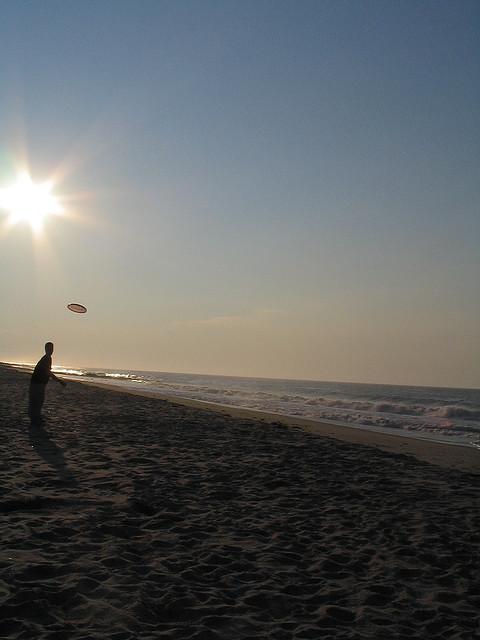Where is the sun in the sky?
Answer briefly. Left. Are there many clouds in the sky?
Give a very brief answer. No. Is it stormy in the image?
Write a very short answer. No. Is this picture taken from the ground?
Quick response, please. Yes. Is there a plane?
Write a very short answer. No. Is the person in the water?
Short answer required. No. Are there clouds in the sky?
Write a very short answer. No. What kind of day is this?
Give a very brief answer. Sunny. Is the sky cloudy?
Keep it brief. No. Where was this picture taken?
Short answer required. Beach. Which side of the picture is the light source coming from?
Write a very short answer. Left. Is this a person's silhouette?
Write a very short answer. Yes. Are there clouds in the picture?
Short answer required. No. Overcast or sunny?
Answer briefly. Sunny. Are there any people in the water?
Keep it brief. No. Is this over water?
Keep it brief. No. Do you a UFO in the sky?
Concise answer only. No. Is the sun close to the ground?
Concise answer only. No. Is this a horse?
Write a very short answer. No. What is the guy flying?
Quick response, please. Kite. Is there a popular name for lakes, starting with P, that describes this beach water?
Concise answer only. No. What color is the water?
Quick response, please. Blue. Is the sun visible?
Concise answer only. Yes. 